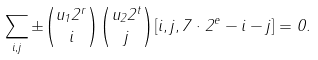<formula> <loc_0><loc_0><loc_500><loc_500>\sum _ { i , j } \pm \binom { u _ { 1 } 2 ^ { r } } i \binom { u _ { 2 } 2 ^ { t } } j [ i , j , 7 \cdot 2 ^ { e } - i - j ] = 0 .</formula> 